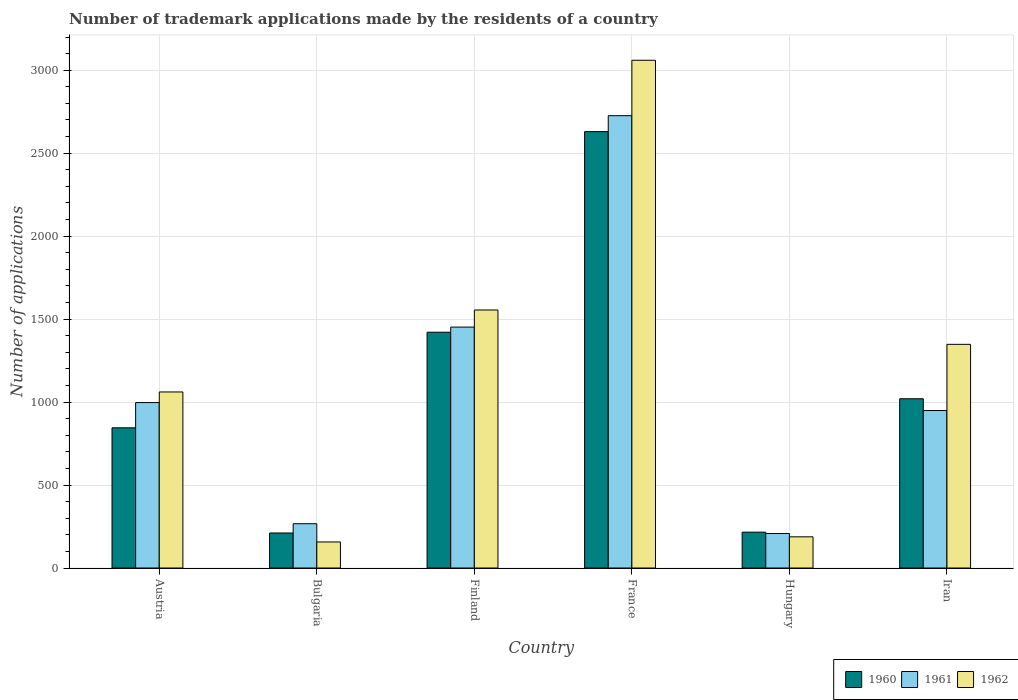Are the number of bars on each tick of the X-axis equal?
Your response must be concise. Yes. What is the label of the 2nd group of bars from the left?
Make the answer very short. Bulgaria. In how many cases, is the number of bars for a given country not equal to the number of legend labels?
Offer a very short reply. 0. What is the number of trademark applications made by the residents in 1961 in France?
Provide a short and direct response. 2726. Across all countries, what is the maximum number of trademark applications made by the residents in 1960?
Offer a very short reply. 2630. Across all countries, what is the minimum number of trademark applications made by the residents in 1961?
Provide a short and direct response. 208. In which country was the number of trademark applications made by the residents in 1961 maximum?
Your response must be concise. France. In which country was the number of trademark applications made by the residents in 1960 minimum?
Keep it short and to the point. Bulgaria. What is the total number of trademark applications made by the residents in 1962 in the graph?
Keep it short and to the point. 7369. What is the difference between the number of trademark applications made by the residents in 1962 in Austria and that in France?
Ensure brevity in your answer.  -1999. What is the difference between the number of trademark applications made by the residents in 1962 in Hungary and the number of trademark applications made by the residents in 1960 in Iran?
Offer a very short reply. -832. What is the average number of trademark applications made by the residents in 1960 per country?
Your response must be concise. 1057.17. What is the difference between the number of trademark applications made by the residents of/in 1961 and number of trademark applications made by the residents of/in 1962 in Iran?
Offer a very short reply. -399. What is the ratio of the number of trademark applications made by the residents in 1961 in Austria to that in Finland?
Provide a succinct answer. 0.69. Is the number of trademark applications made by the residents in 1961 in Bulgaria less than that in Finland?
Give a very brief answer. Yes. Is the difference between the number of trademark applications made by the residents in 1961 in Finland and Iran greater than the difference between the number of trademark applications made by the residents in 1962 in Finland and Iran?
Your answer should be very brief. Yes. What is the difference between the highest and the second highest number of trademark applications made by the residents in 1960?
Offer a terse response. -401. What is the difference between the highest and the lowest number of trademark applications made by the residents in 1961?
Offer a very short reply. 2518. Is it the case that in every country, the sum of the number of trademark applications made by the residents in 1960 and number of trademark applications made by the residents in 1961 is greater than the number of trademark applications made by the residents in 1962?
Your response must be concise. Yes. Are all the bars in the graph horizontal?
Your response must be concise. No. Are the values on the major ticks of Y-axis written in scientific E-notation?
Offer a terse response. No. Does the graph contain any zero values?
Your answer should be very brief. No. Does the graph contain grids?
Provide a succinct answer. Yes. How many legend labels are there?
Provide a short and direct response. 3. How are the legend labels stacked?
Offer a very short reply. Horizontal. What is the title of the graph?
Give a very brief answer. Number of trademark applications made by the residents of a country. What is the label or title of the X-axis?
Offer a terse response. Country. What is the label or title of the Y-axis?
Your answer should be compact. Number of applications. What is the Number of applications in 1960 in Austria?
Your answer should be compact. 845. What is the Number of applications of 1961 in Austria?
Provide a succinct answer. 997. What is the Number of applications of 1962 in Austria?
Provide a succinct answer. 1061. What is the Number of applications in 1960 in Bulgaria?
Offer a terse response. 211. What is the Number of applications in 1961 in Bulgaria?
Your answer should be compact. 267. What is the Number of applications in 1962 in Bulgaria?
Give a very brief answer. 157. What is the Number of applications in 1960 in Finland?
Offer a terse response. 1421. What is the Number of applications in 1961 in Finland?
Ensure brevity in your answer.  1452. What is the Number of applications in 1962 in Finland?
Give a very brief answer. 1555. What is the Number of applications in 1960 in France?
Give a very brief answer. 2630. What is the Number of applications of 1961 in France?
Make the answer very short. 2726. What is the Number of applications of 1962 in France?
Ensure brevity in your answer.  3060. What is the Number of applications of 1960 in Hungary?
Provide a short and direct response. 216. What is the Number of applications in 1961 in Hungary?
Keep it short and to the point. 208. What is the Number of applications in 1962 in Hungary?
Your answer should be very brief. 188. What is the Number of applications of 1960 in Iran?
Keep it short and to the point. 1020. What is the Number of applications in 1961 in Iran?
Offer a very short reply. 949. What is the Number of applications of 1962 in Iran?
Ensure brevity in your answer.  1348. Across all countries, what is the maximum Number of applications in 1960?
Provide a succinct answer. 2630. Across all countries, what is the maximum Number of applications in 1961?
Your answer should be compact. 2726. Across all countries, what is the maximum Number of applications in 1962?
Give a very brief answer. 3060. Across all countries, what is the minimum Number of applications in 1960?
Make the answer very short. 211. Across all countries, what is the minimum Number of applications of 1961?
Your response must be concise. 208. Across all countries, what is the minimum Number of applications of 1962?
Make the answer very short. 157. What is the total Number of applications of 1960 in the graph?
Keep it short and to the point. 6343. What is the total Number of applications of 1961 in the graph?
Make the answer very short. 6599. What is the total Number of applications in 1962 in the graph?
Provide a short and direct response. 7369. What is the difference between the Number of applications of 1960 in Austria and that in Bulgaria?
Offer a very short reply. 634. What is the difference between the Number of applications in 1961 in Austria and that in Bulgaria?
Provide a succinct answer. 730. What is the difference between the Number of applications in 1962 in Austria and that in Bulgaria?
Provide a short and direct response. 904. What is the difference between the Number of applications of 1960 in Austria and that in Finland?
Offer a very short reply. -576. What is the difference between the Number of applications of 1961 in Austria and that in Finland?
Provide a short and direct response. -455. What is the difference between the Number of applications in 1962 in Austria and that in Finland?
Provide a succinct answer. -494. What is the difference between the Number of applications of 1960 in Austria and that in France?
Offer a very short reply. -1785. What is the difference between the Number of applications of 1961 in Austria and that in France?
Your response must be concise. -1729. What is the difference between the Number of applications in 1962 in Austria and that in France?
Keep it short and to the point. -1999. What is the difference between the Number of applications in 1960 in Austria and that in Hungary?
Offer a terse response. 629. What is the difference between the Number of applications of 1961 in Austria and that in Hungary?
Your answer should be very brief. 789. What is the difference between the Number of applications in 1962 in Austria and that in Hungary?
Offer a very short reply. 873. What is the difference between the Number of applications of 1960 in Austria and that in Iran?
Ensure brevity in your answer.  -175. What is the difference between the Number of applications in 1962 in Austria and that in Iran?
Your response must be concise. -287. What is the difference between the Number of applications of 1960 in Bulgaria and that in Finland?
Offer a terse response. -1210. What is the difference between the Number of applications in 1961 in Bulgaria and that in Finland?
Provide a short and direct response. -1185. What is the difference between the Number of applications of 1962 in Bulgaria and that in Finland?
Offer a terse response. -1398. What is the difference between the Number of applications of 1960 in Bulgaria and that in France?
Offer a terse response. -2419. What is the difference between the Number of applications in 1961 in Bulgaria and that in France?
Offer a very short reply. -2459. What is the difference between the Number of applications of 1962 in Bulgaria and that in France?
Offer a very short reply. -2903. What is the difference between the Number of applications in 1962 in Bulgaria and that in Hungary?
Make the answer very short. -31. What is the difference between the Number of applications in 1960 in Bulgaria and that in Iran?
Your answer should be very brief. -809. What is the difference between the Number of applications in 1961 in Bulgaria and that in Iran?
Make the answer very short. -682. What is the difference between the Number of applications in 1962 in Bulgaria and that in Iran?
Provide a short and direct response. -1191. What is the difference between the Number of applications of 1960 in Finland and that in France?
Your answer should be very brief. -1209. What is the difference between the Number of applications in 1961 in Finland and that in France?
Provide a short and direct response. -1274. What is the difference between the Number of applications of 1962 in Finland and that in France?
Provide a succinct answer. -1505. What is the difference between the Number of applications in 1960 in Finland and that in Hungary?
Your answer should be very brief. 1205. What is the difference between the Number of applications in 1961 in Finland and that in Hungary?
Your response must be concise. 1244. What is the difference between the Number of applications of 1962 in Finland and that in Hungary?
Give a very brief answer. 1367. What is the difference between the Number of applications in 1960 in Finland and that in Iran?
Offer a very short reply. 401. What is the difference between the Number of applications in 1961 in Finland and that in Iran?
Make the answer very short. 503. What is the difference between the Number of applications in 1962 in Finland and that in Iran?
Provide a succinct answer. 207. What is the difference between the Number of applications of 1960 in France and that in Hungary?
Ensure brevity in your answer.  2414. What is the difference between the Number of applications in 1961 in France and that in Hungary?
Make the answer very short. 2518. What is the difference between the Number of applications in 1962 in France and that in Hungary?
Keep it short and to the point. 2872. What is the difference between the Number of applications of 1960 in France and that in Iran?
Your response must be concise. 1610. What is the difference between the Number of applications of 1961 in France and that in Iran?
Provide a succinct answer. 1777. What is the difference between the Number of applications in 1962 in France and that in Iran?
Provide a succinct answer. 1712. What is the difference between the Number of applications in 1960 in Hungary and that in Iran?
Provide a short and direct response. -804. What is the difference between the Number of applications of 1961 in Hungary and that in Iran?
Offer a very short reply. -741. What is the difference between the Number of applications in 1962 in Hungary and that in Iran?
Keep it short and to the point. -1160. What is the difference between the Number of applications in 1960 in Austria and the Number of applications in 1961 in Bulgaria?
Your answer should be very brief. 578. What is the difference between the Number of applications in 1960 in Austria and the Number of applications in 1962 in Bulgaria?
Ensure brevity in your answer.  688. What is the difference between the Number of applications in 1961 in Austria and the Number of applications in 1962 in Bulgaria?
Keep it short and to the point. 840. What is the difference between the Number of applications of 1960 in Austria and the Number of applications of 1961 in Finland?
Your answer should be very brief. -607. What is the difference between the Number of applications in 1960 in Austria and the Number of applications in 1962 in Finland?
Your response must be concise. -710. What is the difference between the Number of applications of 1961 in Austria and the Number of applications of 1962 in Finland?
Provide a succinct answer. -558. What is the difference between the Number of applications of 1960 in Austria and the Number of applications of 1961 in France?
Keep it short and to the point. -1881. What is the difference between the Number of applications in 1960 in Austria and the Number of applications in 1962 in France?
Offer a very short reply. -2215. What is the difference between the Number of applications in 1961 in Austria and the Number of applications in 1962 in France?
Provide a short and direct response. -2063. What is the difference between the Number of applications of 1960 in Austria and the Number of applications of 1961 in Hungary?
Make the answer very short. 637. What is the difference between the Number of applications of 1960 in Austria and the Number of applications of 1962 in Hungary?
Your answer should be very brief. 657. What is the difference between the Number of applications of 1961 in Austria and the Number of applications of 1962 in Hungary?
Your response must be concise. 809. What is the difference between the Number of applications of 1960 in Austria and the Number of applications of 1961 in Iran?
Give a very brief answer. -104. What is the difference between the Number of applications of 1960 in Austria and the Number of applications of 1962 in Iran?
Make the answer very short. -503. What is the difference between the Number of applications of 1961 in Austria and the Number of applications of 1962 in Iran?
Provide a short and direct response. -351. What is the difference between the Number of applications in 1960 in Bulgaria and the Number of applications in 1961 in Finland?
Keep it short and to the point. -1241. What is the difference between the Number of applications in 1960 in Bulgaria and the Number of applications in 1962 in Finland?
Keep it short and to the point. -1344. What is the difference between the Number of applications of 1961 in Bulgaria and the Number of applications of 1962 in Finland?
Keep it short and to the point. -1288. What is the difference between the Number of applications of 1960 in Bulgaria and the Number of applications of 1961 in France?
Offer a very short reply. -2515. What is the difference between the Number of applications of 1960 in Bulgaria and the Number of applications of 1962 in France?
Your answer should be very brief. -2849. What is the difference between the Number of applications of 1961 in Bulgaria and the Number of applications of 1962 in France?
Provide a short and direct response. -2793. What is the difference between the Number of applications of 1960 in Bulgaria and the Number of applications of 1961 in Hungary?
Ensure brevity in your answer.  3. What is the difference between the Number of applications of 1960 in Bulgaria and the Number of applications of 1962 in Hungary?
Keep it short and to the point. 23. What is the difference between the Number of applications in 1961 in Bulgaria and the Number of applications in 1962 in Hungary?
Offer a terse response. 79. What is the difference between the Number of applications of 1960 in Bulgaria and the Number of applications of 1961 in Iran?
Provide a short and direct response. -738. What is the difference between the Number of applications in 1960 in Bulgaria and the Number of applications in 1962 in Iran?
Provide a short and direct response. -1137. What is the difference between the Number of applications in 1961 in Bulgaria and the Number of applications in 1962 in Iran?
Your response must be concise. -1081. What is the difference between the Number of applications of 1960 in Finland and the Number of applications of 1961 in France?
Offer a terse response. -1305. What is the difference between the Number of applications of 1960 in Finland and the Number of applications of 1962 in France?
Provide a short and direct response. -1639. What is the difference between the Number of applications of 1961 in Finland and the Number of applications of 1962 in France?
Offer a very short reply. -1608. What is the difference between the Number of applications in 1960 in Finland and the Number of applications in 1961 in Hungary?
Offer a terse response. 1213. What is the difference between the Number of applications in 1960 in Finland and the Number of applications in 1962 in Hungary?
Ensure brevity in your answer.  1233. What is the difference between the Number of applications of 1961 in Finland and the Number of applications of 1962 in Hungary?
Your response must be concise. 1264. What is the difference between the Number of applications of 1960 in Finland and the Number of applications of 1961 in Iran?
Keep it short and to the point. 472. What is the difference between the Number of applications of 1960 in Finland and the Number of applications of 1962 in Iran?
Your answer should be compact. 73. What is the difference between the Number of applications of 1961 in Finland and the Number of applications of 1962 in Iran?
Keep it short and to the point. 104. What is the difference between the Number of applications in 1960 in France and the Number of applications in 1961 in Hungary?
Your answer should be compact. 2422. What is the difference between the Number of applications in 1960 in France and the Number of applications in 1962 in Hungary?
Your response must be concise. 2442. What is the difference between the Number of applications of 1961 in France and the Number of applications of 1962 in Hungary?
Provide a succinct answer. 2538. What is the difference between the Number of applications of 1960 in France and the Number of applications of 1961 in Iran?
Ensure brevity in your answer.  1681. What is the difference between the Number of applications in 1960 in France and the Number of applications in 1962 in Iran?
Your response must be concise. 1282. What is the difference between the Number of applications in 1961 in France and the Number of applications in 1962 in Iran?
Ensure brevity in your answer.  1378. What is the difference between the Number of applications in 1960 in Hungary and the Number of applications in 1961 in Iran?
Make the answer very short. -733. What is the difference between the Number of applications of 1960 in Hungary and the Number of applications of 1962 in Iran?
Make the answer very short. -1132. What is the difference between the Number of applications of 1961 in Hungary and the Number of applications of 1962 in Iran?
Your answer should be compact. -1140. What is the average Number of applications in 1960 per country?
Keep it short and to the point. 1057.17. What is the average Number of applications in 1961 per country?
Make the answer very short. 1099.83. What is the average Number of applications of 1962 per country?
Offer a terse response. 1228.17. What is the difference between the Number of applications in 1960 and Number of applications in 1961 in Austria?
Your answer should be very brief. -152. What is the difference between the Number of applications in 1960 and Number of applications in 1962 in Austria?
Offer a very short reply. -216. What is the difference between the Number of applications of 1961 and Number of applications of 1962 in Austria?
Your answer should be very brief. -64. What is the difference between the Number of applications in 1960 and Number of applications in 1961 in Bulgaria?
Give a very brief answer. -56. What is the difference between the Number of applications in 1960 and Number of applications in 1962 in Bulgaria?
Your answer should be very brief. 54. What is the difference between the Number of applications of 1961 and Number of applications of 1962 in Bulgaria?
Provide a short and direct response. 110. What is the difference between the Number of applications in 1960 and Number of applications in 1961 in Finland?
Your response must be concise. -31. What is the difference between the Number of applications of 1960 and Number of applications of 1962 in Finland?
Offer a very short reply. -134. What is the difference between the Number of applications in 1961 and Number of applications in 1962 in Finland?
Offer a very short reply. -103. What is the difference between the Number of applications of 1960 and Number of applications of 1961 in France?
Your answer should be compact. -96. What is the difference between the Number of applications in 1960 and Number of applications in 1962 in France?
Provide a succinct answer. -430. What is the difference between the Number of applications of 1961 and Number of applications of 1962 in France?
Your answer should be compact. -334. What is the difference between the Number of applications in 1960 and Number of applications in 1962 in Hungary?
Your response must be concise. 28. What is the difference between the Number of applications in 1960 and Number of applications in 1961 in Iran?
Make the answer very short. 71. What is the difference between the Number of applications of 1960 and Number of applications of 1962 in Iran?
Give a very brief answer. -328. What is the difference between the Number of applications of 1961 and Number of applications of 1962 in Iran?
Keep it short and to the point. -399. What is the ratio of the Number of applications of 1960 in Austria to that in Bulgaria?
Your answer should be very brief. 4. What is the ratio of the Number of applications in 1961 in Austria to that in Bulgaria?
Provide a short and direct response. 3.73. What is the ratio of the Number of applications in 1962 in Austria to that in Bulgaria?
Provide a short and direct response. 6.76. What is the ratio of the Number of applications of 1960 in Austria to that in Finland?
Offer a very short reply. 0.59. What is the ratio of the Number of applications in 1961 in Austria to that in Finland?
Keep it short and to the point. 0.69. What is the ratio of the Number of applications of 1962 in Austria to that in Finland?
Your response must be concise. 0.68. What is the ratio of the Number of applications of 1960 in Austria to that in France?
Your response must be concise. 0.32. What is the ratio of the Number of applications of 1961 in Austria to that in France?
Your answer should be very brief. 0.37. What is the ratio of the Number of applications in 1962 in Austria to that in France?
Your response must be concise. 0.35. What is the ratio of the Number of applications in 1960 in Austria to that in Hungary?
Provide a succinct answer. 3.91. What is the ratio of the Number of applications of 1961 in Austria to that in Hungary?
Keep it short and to the point. 4.79. What is the ratio of the Number of applications of 1962 in Austria to that in Hungary?
Your response must be concise. 5.64. What is the ratio of the Number of applications in 1960 in Austria to that in Iran?
Give a very brief answer. 0.83. What is the ratio of the Number of applications in 1961 in Austria to that in Iran?
Your answer should be very brief. 1.05. What is the ratio of the Number of applications in 1962 in Austria to that in Iran?
Give a very brief answer. 0.79. What is the ratio of the Number of applications of 1960 in Bulgaria to that in Finland?
Make the answer very short. 0.15. What is the ratio of the Number of applications of 1961 in Bulgaria to that in Finland?
Your answer should be very brief. 0.18. What is the ratio of the Number of applications in 1962 in Bulgaria to that in Finland?
Your response must be concise. 0.1. What is the ratio of the Number of applications of 1960 in Bulgaria to that in France?
Your answer should be compact. 0.08. What is the ratio of the Number of applications in 1961 in Bulgaria to that in France?
Offer a very short reply. 0.1. What is the ratio of the Number of applications of 1962 in Bulgaria to that in France?
Keep it short and to the point. 0.05. What is the ratio of the Number of applications of 1960 in Bulgaria to that in Hungary?
Offer a very short reply. 0.98. What is the ratio of the Number of applications in 1961 in Bulgaria to that in Hungary?
Keep it short and to the point. 1.28. What is the ratio of the Number of applications in 1962 in Bulgaria to that in Hungary?
Ensure brevity in your answer.  0.84. What is the ratio of the Number of applications in 1960 in Bulgaria to that in Iran?
Ensure brevity in your answer.  0.21. What is the ratio of the Number of applications of 1961 in Bulgaria to that in Iran?
Ensure brevity in your answer.  0.28. What is the ratio of the Number of applications in 1962 in Bulgaria to that in Iran?
Ensure brevity in your answer.  0.12. What is the ratio of the Number of applications of 1960 in Finland to that in France?
Provide a succinct answer. 0.54. What is the ratio of the Number of applications of 1961 in Finland to that in France?
Your response must be concise. 0.53. What is the ratio of the Number of applications in 1962 in Finland to that in France?
Your answer should be compact. 0.51. What is the ratio of the Number of applications of 1960 in Finland to that in Hungary?
Keep it short and to the point. 6.58. What is the ratio of the Number of applications of 1961 in Finland to that in Hungary?
Ensure brevity in your answer.  6.98. What is the ratio of the Number of applications in 1962 in Finland to that in Hungary?
Provide a short and direct response. 8.27. What is the ratio of the Number of applications of 1960 in Finland to that in Iran?
Keep it short and to the point. 1.39. What is the ratio of the Number of applications of 1961 in Finland to that in Iran?
Make the answer very short. 1.53. What is the ratio of the Number of applications of 1962 in Finland to that in Iran?
Your answer should be very brief. 1.15. What is the ratio of the Number of applications in 1960 in France to that in Hungary?
Ensure brevity in your answer.  12.18. What is the ratio of the Number of applications of 1961 in France to that in Hungary?
Offer a very short reply. 13.11. What is the ratio of the Number of applications of 1962 in France to that in Hungary?
Offer a terse response. 16.28. What is the ratio of the Number of applications in 1960 in France to that in Iran?
Offer a terse response. 2.58. What is the ratio of the Number of applications in 1961 in France to that in Iran?
Offer a very short reply. 2.87. What is the ratio of the Number of applications of 1962 in France to that in Iran?
Your answer should be compact. 2.27. What is the ratio of the Number of applications in 1960 in Hungary to that in Iran?
Offer a very short reply. 0.21. What is the ratio of the Number of applications of 1961 in Hungary to that in Iran?
Give a very brief answer. 0.22. What is the ratio of the Number of applications of 1962 in Hungary to that in Iran?
Your response must be concise. 0.14. What is the difference between the highest and the second highest Number of applications in 1960?
Make the answer very short. 1209. What is the difference between the highest and the second highest Number of applications in 1961?
Make the answer very short. 1274. What is the difference between the highest and the second highest Number of applications of 1962?
Ensure brevity in your answer.  1505. What is the difference between the highest and the lowest Number of applications of 1960?
Give a very brief answer. 2419. What is the difference between the highest and the lowest Number of applications in 1961?
Your answer should be compact. 2518. What is the difference between the highest and the lowest Number of applications in 1962?
Your answer should be very brief. 2903. 